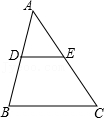What geometrical principles are illustrated in the construction of triangle ADE? The construction of triangle ADE demonstrates several fundamental principles of geometry, including the Midsegment Theorem, which states that a segment connecting the midpoints of two sides of a triangle is parallel to the third side and half its length. This principle is evidenced by DE being parallel and half the length of BC. Additionally, the scenario illustrates concepts of triangle similarity and the properties of bisected lines, crucial for deducing properties of geometric figures efficiently and accurately. 